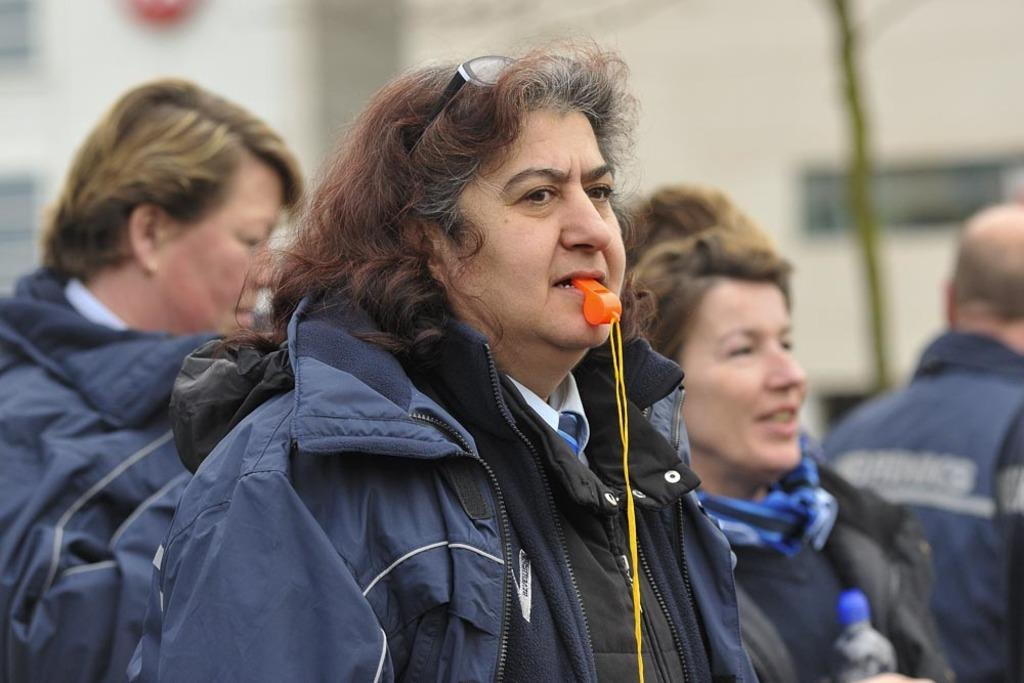How many people are in the image? There are people in the image, but the exact number is not specified. What are the people wearing in the image? The people are wearing jackets in the image. What object can be seen in the person's mouth? There is a whistle in the person's mouth in the image. What type of loss is being experienced by the people in the image? There is no indication of any loss being experienced by the people in the image. Can you see a bucket in the image? There is no mention of a bucket in the image. 